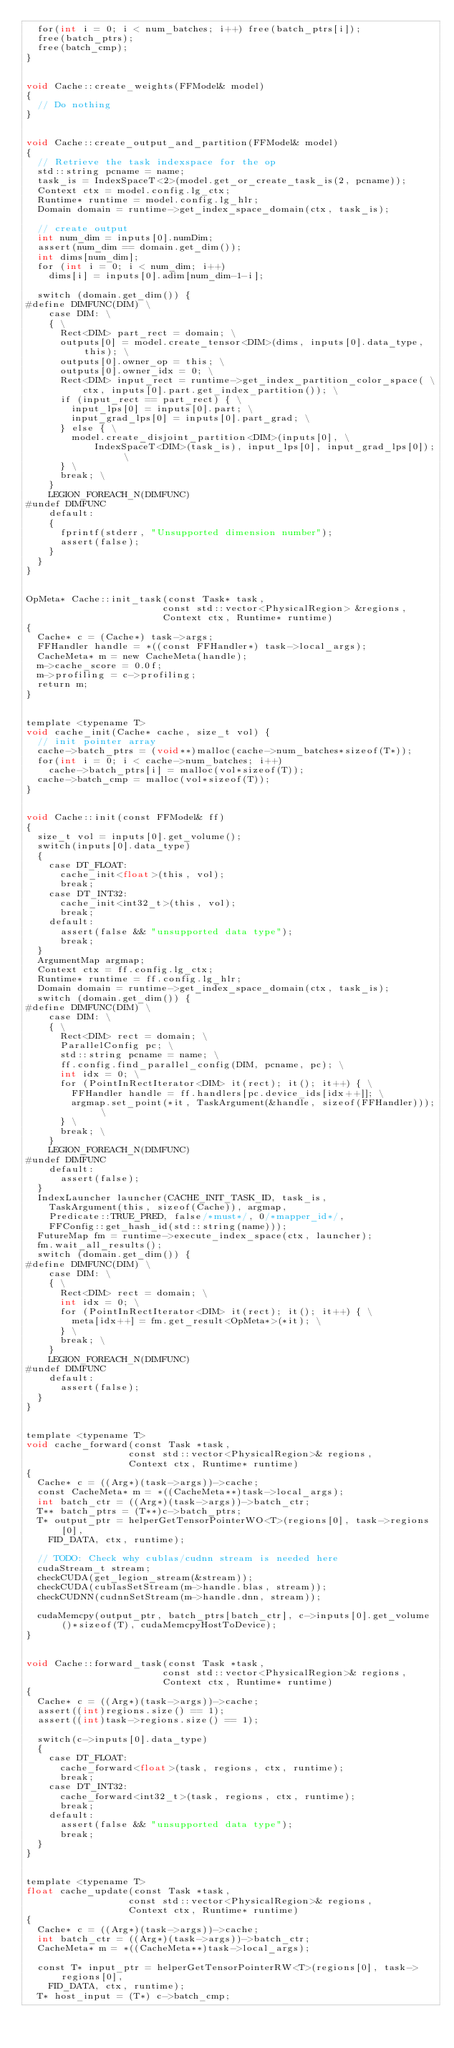<code> <loc_0><loc_0><loc_500><loc_500><_Cuda_>  for(int i = 0; i < num_batches; i++) free(batch_ptrs[i]);
  free(batch_ptrs);
  free(batch_cmp);
}


void Cache::create_weights(FFModel& model)
{
  // Do nothing
}


void Cache::create_output_and_partition(FFModel& model)
{
  // Retrieve the task indexspace for the op
  std::string pcname = name;
  task_is = IndexSpaceT<2>(model.get_or_create_task_is(2, pcname));
  Context ctx = model.config.lg_ctx;
  Runtime* runtime = model.config.lg_hlr;
  Domain domain = runtime->get_index_space_domain(ctx, task_is);

  // create output
  int num_dim = inputs[0].numDim;
  assert(num_dim == domain.get_dim());
  int dims[num_dim];
  for (int i = 0; i < num_dim; i++)
    dims[i] = inputs[0].adim[num_dim-1-i];

  switch (domain.get_dim()) {
#define DIMFUNC(DIM) \
    case DIM: \
    { \
      Rect<DIM> part_rect = domain; \
      outputs[0] = model.create_tensor<DIM>(dims, inputs[0].data_type, this); \
      outputs[0].owner_op = this; \
      outputs[0].owner_idx = 0; \
      Rect<DIM> input_rect = runtime->get_index_partition_color_space( \
          ctx, inputs[0].part.get_index_partition()); \
      if (input_rect == part_rect) { \
        input_lps[0] = inputs[0].part; \
        input_grad_lps[0] = inputs[0].part_grad; \
      } else { \
        model.create_disjoint_partition<DIM>(inputs[0], \
            IndexSpaceT<DIM>(task_is), input_lps[0], input_grad_lps[0]); \
      } \
      break; \
    }
    LEGION_FOREACH_N(DIMFUNC)
#undef DIMFUNC
    default:
    {
      fprintf(stderr, "Unsupported dimension number");
      assert(false);
    }
  }
}


OpMeta* Cache::init_task(const Task* task,
                        const std::vector<PhysicalRegion> &regions,
                        Context ctx, Runtime* runtime)
{
  Cache* c = (Cache*) task->args;
  FFHandler handle = *((const FFHandler*) task->local_args);
  CacheMeta* m = new CacheMeta(handle);
  m->cache_score = 0.0f;
  m->profiling = c->profiling;
  return m;
}


template <typename T>
void cache_init(Cache* cache, size_t vol) {
  // init pointer array
  cache->batch_ptrs = (void**)malloc(cache->num_batches*sizeof(T*));
  for(int i = 0; i < cache->num_batches; i++)
    cache->batch_ptrs[i] = malloc(vol*sizeof(T));
  cache->batch_cmp = malloc(vol*sizeof(T));
}


void Cache::init(const FFModel& ff)
{
  size_t vol = inputs[0].get_volume();
  switch(inputs[0].data_type)
  {
    case DT_FLOAT:
      cache_init<float>(this, vol);
      break;
    case DT_INT32:
      cache_init<int32_t>(this, vol);
      break;
    default:
      assert(false && "unsupported data type");
      break;
  }
  ArgumentMap argmap;
  Context ctx = ff.config.lg_ctx;
  Runtime* runtime = ff.config.lg_hlr;
  Domain domain = runtime->get_index_space_domain(ctx, task_is);
  switch (domain.get_dim()) {
#define DIMFUNC(DIM) \
    case DIM: \
    { \
      Rect<DIM> rect = domain; \
      ParallelConfig pc; \
      std::string pcname = name; \
      ff.config.find_parallel_config(DIM, pcname, pc); \
      int idx = 0; \
      for (PointInRectIterator<DIM> it(rect); it(); it++) { \
        FFHandler handle = ff.handlers[pc.device_ids[idx++]]; \
        argmap.set_point(*it, TaskArgument(&handle, sizeof(FFHandler))); \
      } \
      break; \
    }
    LEGION_FOREACH_N(DIMFUNC)
#undef DIMFUNC
    default:
      assert(false);
  }
  IndexLauncher launcher(CACHE_INIT_TASK_ID, task_is,
    TaskArgument(this, sizeof(Cache)), argmap,
    Predicate::TRUE_PRED, false/*must*/, 0/*mapper_id*/,
    FFConfig::get_hash_id(std::string(name)));
  FutureMap fm = runtime->execute_index_space(ctx, launcher);
  fm.wait_all_results();
  switch (domain.get_dim()) {
#define DIMFUNC(DIM) \
    case DIM: \
    { \
      Rect<DIM> rect = domain; \
      int idx = 0; \
      for (PointInRectIterator<DIM> it(rect); it(); it++) { \
        meta[idx++] = fm.get_result<OpMeta*>(*it); \
      } \
      break; \
    }
    LEGION_FOREACH_N(DIMFUNC)
#undef DIMFUNC
    default:
      assert(false);
  }
}


template <typename T>
void cache_forward(const Task *task,
                  const std::vector<PhysicalRegion>& regions,
                  Context ctx, Runtime* runtime)
{
  Cache* c = ((Arg*)(task->args))->cache;
  const CacheMeta* m = *((CacheMeta**)task->local_args);
  int batch_ctr = ((Arg*)(task->args))->batch_ctr;
  T** batch_ptrs = (T**)c->batch_ptrs;
  T* output_ptr = helperGetTensorPointerWO<T>(regions[0], task->regions[0],
    FID_DATA, ctx, runtime);

  // TODO: Check why cublas/cudnn stream is needed here
  cudaStream_t stream;
  checkCUDA(get_legion_stream(&stream));
  checkCUDA(cublasSetStream(m->handle.blas, stream));
  checkCUDNN(cudnnSetStream(m->handle.dnn, stream));

  cudaMemcpy(output_ptr, batch_ptrs[batch_ctr], c->inputs[0].get_volume()*sizeof(T), cudaMemcpyHostToDevice);
}


void Cache::forward_task(const Task *task,
                        const std::vector<PhysicalRegion>& regions,
                        Context ctx, Runtime* runtime)
{
  Cache* c = ((Arg*)(task->args))->cache;
  assert((int)regions.size() == 1);
  assert((int)task->regions.size() == 1);

  switch(c->inputs[0].data_type)
  {
    case DT_FLOAT:
      cache_forward<float>(task, regions, ctx, runtime);
      break;
    case DT_INT32:
      cache_forward<int32_t>(task, regions, ctx, runtime);
      break;
    default:
      assert(false && "unsupported data type");
      break;
  }
}


template <typename T>
float cache_update(const Task *task,
                  const std::vector<PhysicalRegion>& regions,
                  Context ctx, Runtime* runtime)
{
  Cache* c = ((Arg*)(task->args))->cache;
  int batch_ctr = ((Arg*)(task->args))->batch_ctr;
  CacheMeta* m = *((CacheMeta**)task->local_args);

  const T* input_ptr = helperGetTensorPointerRW<T>(regions[0], task->regions[0],
    FID_DATA, ctx, runtime);
  T* host_input = (T*) c->batch_cmp;</code> 